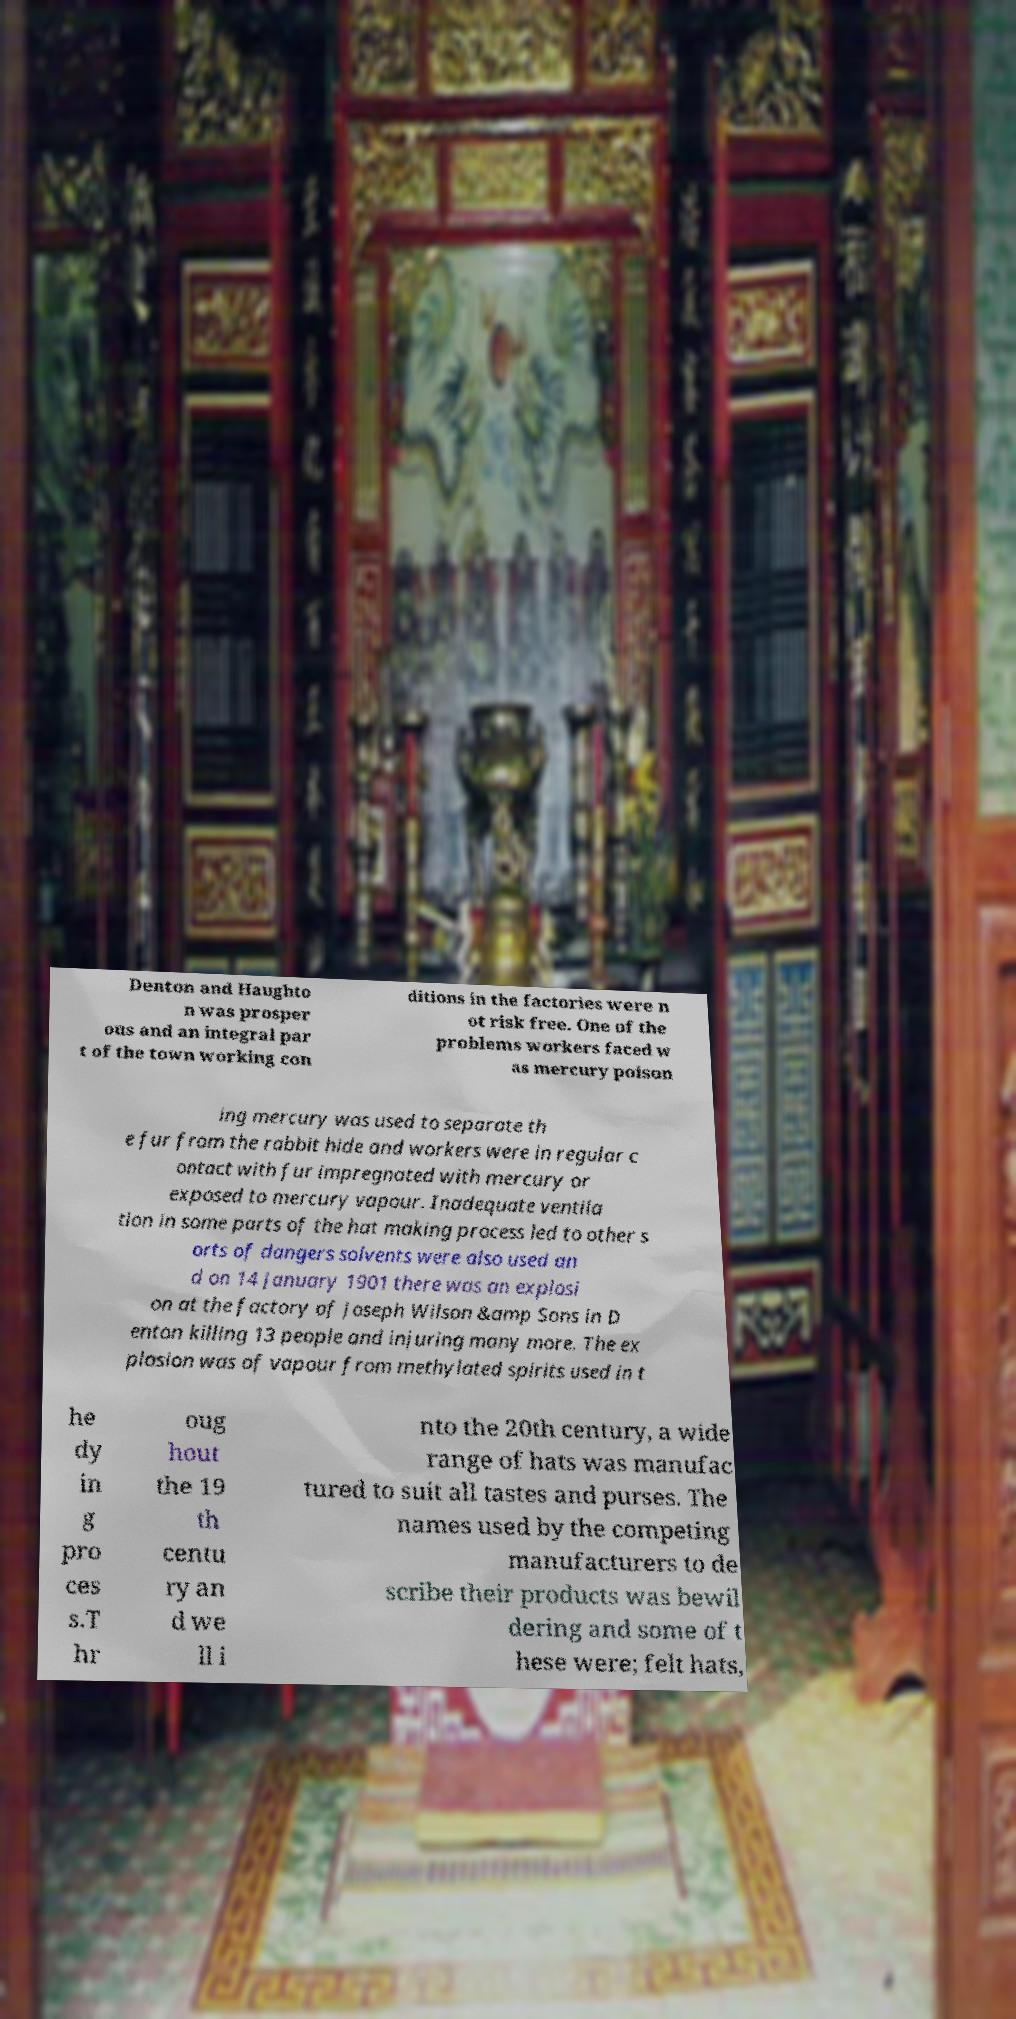Could you extract and type out the text from this image? Denton and Haughto n was prosper ous and an integral par t of the town working con ditions in the factories were n ot risk free. One of the problems workers faced w as mercury poison ing mercury was used to separate th e fur from the rabbit hide and workers were in regular c ontact with fur impregnated with mercury or exposed to mercury vapour. Inadequate ventila tion in some parts of the hat making process led to other s orts of dangers solvents were also used an d on 14 January 1901 there was an explosi on at the factory of Joseph Wilson &amp Sons in D enton killing 13 people and injuring many more. The ex plosion was of vapour from methylated spirits used in t he dy in g pro ces s.T hr oug hout the 19 th centu ry an d we ll i nto the 20th century, a wide range of hats was manufac tured to suit all tastes and purses. The names used by the competing manufacturers to de scribe their products was bewil dering and some of t hese were; felt hats, 